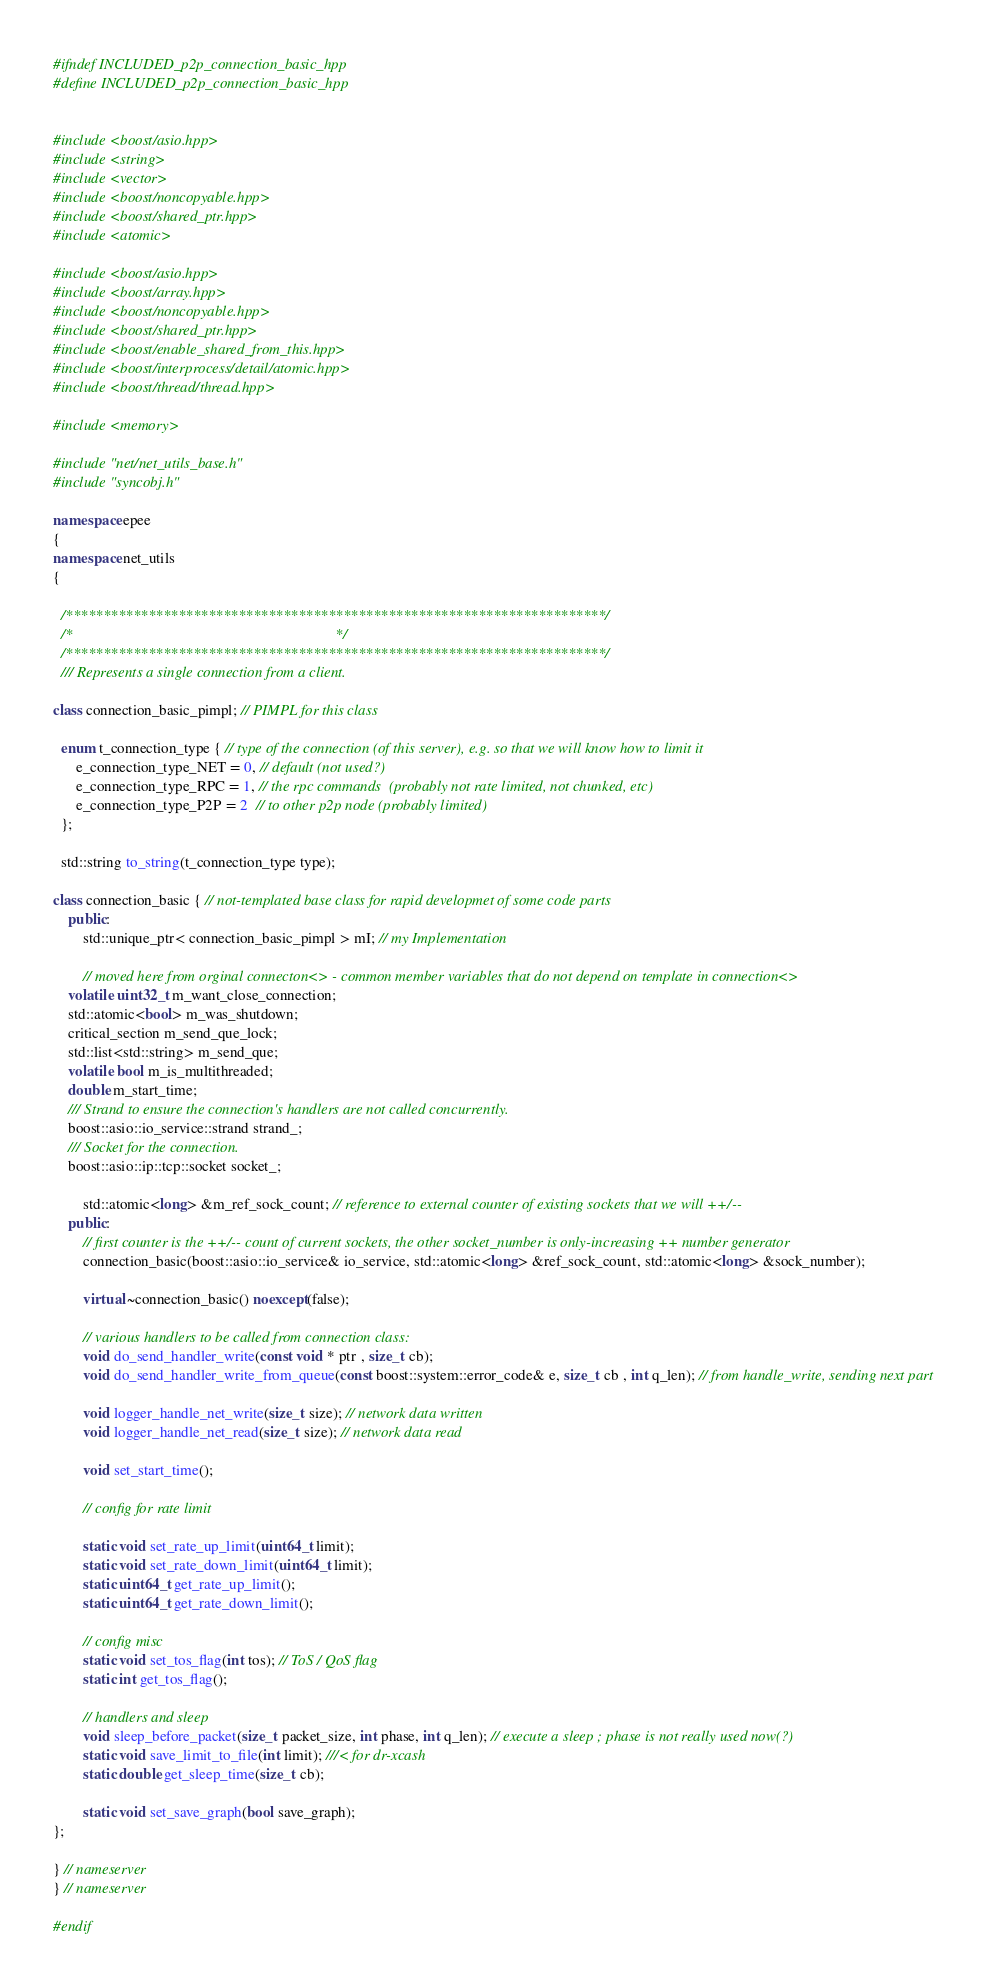<code> <loc_0><loc_0><loc_500><loc_500><_C++_>
#ifndef INCLUDED_p2p_connection_basic_hpp
#define INCLUDED_p2p_connection_basic_hpp


#include <boost/asio.hpp>
#include <string>
#include <vector>
#include <boost/noncopyable.hpp>
#include <boost/shared_ptr.hpp>
#include <atomic>

#include <boost/asio.hpp>
#include <boost/array.hpp>
#include <boost/noncopyable.hpp>
#include <boost/shared_ptr.hpp>
#include <boost/enable_shared_from_this.hpp>
#include <boost/interprocess/detail/atomic.hpp>
#include <boost/thread/thread.hpp>

#include <memory>

#include "net/net_utils_base.h"
#include "syncobj.h"

namespace epee
{
namespace net_utils
{

  /************************************************************************/
  /*                                                                      */
  /************************************************************************/
  /// Represents a single connection from a client.

class connection_basic_pimpl; // PIMPL for this class

  enum t_connection_type { // type of the connection (of this server), e.g. so that we will know how to limit it
	  e_connection_type_NET = 0, // default (not used?)
	  e_connection_type_RPC = 1, // the rpc commands  (probably not rate limited, not chunked, etc)
	  e_connection_type_P2P = 2  // to other p2p node (probably limited)
  };
  
  std::string to_string(t_connection_type type);

class connection_basic { // not-templated base class for rapid developmet of some code parts
	public:
		std::unique_ptr< connection_basic_pimpl > mI; // my Implementation

		// moved here from orginal connecton<> - common member variables that do not depend on template in connection<>
    volatile uint32_t m_want_close_connection;
    std::atomic<bool> m_was_shutdown;
    critical_section m_send_que_lock;
    std::list<std::string> m_send_que;
    volatile bool m_is_multithreaded;
    double m_start_time;
    /// Strand to ensure the connection's handlers are not called concurrently.
    boost::asio::io_service::strand strand_;
    /// Socket for the connection.
    boost::asio::ip::tcp::socket socket_;

		std::atomic<long> &m_ref_sock_count; // reference to external counter of existing sockets that we will ++/--
	public:
		// first counter is the ++/-- count of current sockets, the other socket_number is only-increasing ++ number generator
		connection_basic(boost::asio::io_service& io_service, std::atomic<long> &ref_sock_count, std::atomic<long> &sock_number);

		virtual ~connection_basic() noexcept(false);

		// various handlers to be called from connection class:
		void do_send_handler_write(const void * ptr , size_t cb);
		void do_send_handler_write_from_queue(const boost::system::error_code& e, size_t cb , int q_len); // from handle_write, sending next part

		void logger_handle_net_write(size_t size); // network data written
		void logger_handle_net_read(size_t size); // network data read

		void set_start_time();

		// config for rate limit
		
		static void set_rate_up_limit(uint64_t limit);
		static void set_rate_down_limit(uint64_t limit);
		static uint64_t get_rate_up_limit();
		static uint64_t get_rate_down_limit();

		// config misc
		static void set_tos_flag(int tos); // ToS / QoS flag
		static int get_tos_flag();

		// handlers and sleep
		void sleep_before_packet(size_t packet_size, int phase, int q_len); // execute a sleep ; phase is not really used now(?)
		static void save_limit_to_file(int limit); ///< for dr-xcash
		static double get_sleep_time(size_t cb);
		
		static void set_save_graph(bool save_graph);
};

} // nameserver
} // nameserver

#endif


</code> 